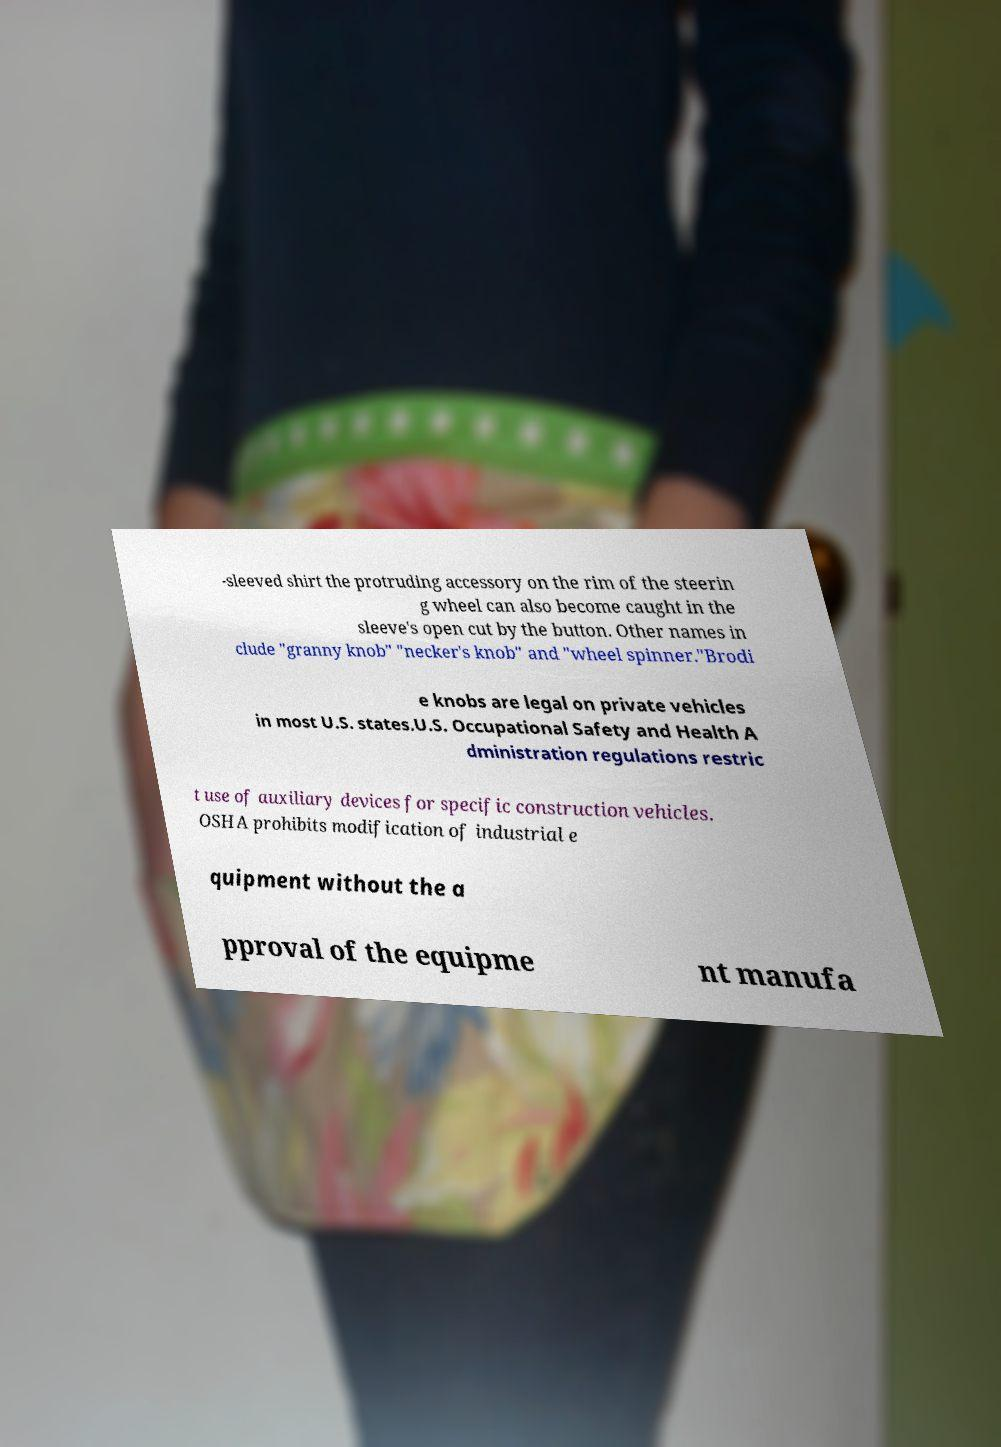Can you accurately transcribe the text from the provided image for me? -sleeved shirt the protruding accessory on the rim of the steerin g wheel can also become caught in the sleeve's open cut by the button. Other names in clude "granny knob" "necker's knob" and "wheel spinner."Brodi e knobs are legal on private vehicles in most U.S. states.U.S. Occupational Safety and Health A dministration regulations restric t use of auxiliary devices for specific construction vehicles. OSHA prohibits modification of industrial e quipment without the a pproval of the equipme nt manufa 